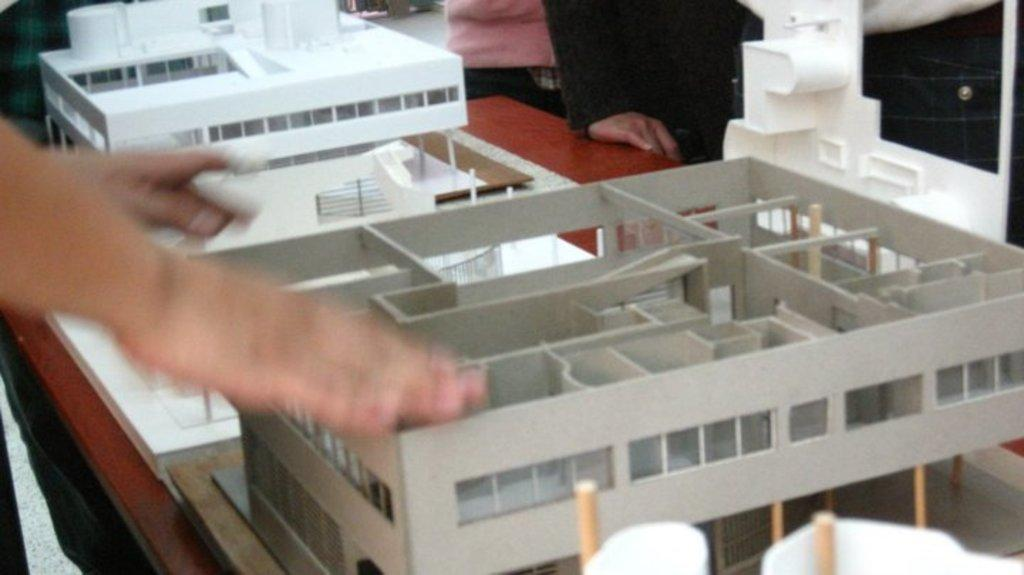What is happening in the image? There are persons in front of a table in the image. What can be seen on the table? The table contains building models. How many divisions are present in the image? There is no division mentioned or visible in the image. What type of pigs can be seen in the image? There are no pigs present in the image. Can you see any icicles in the image? There are no icicles present in the image. 